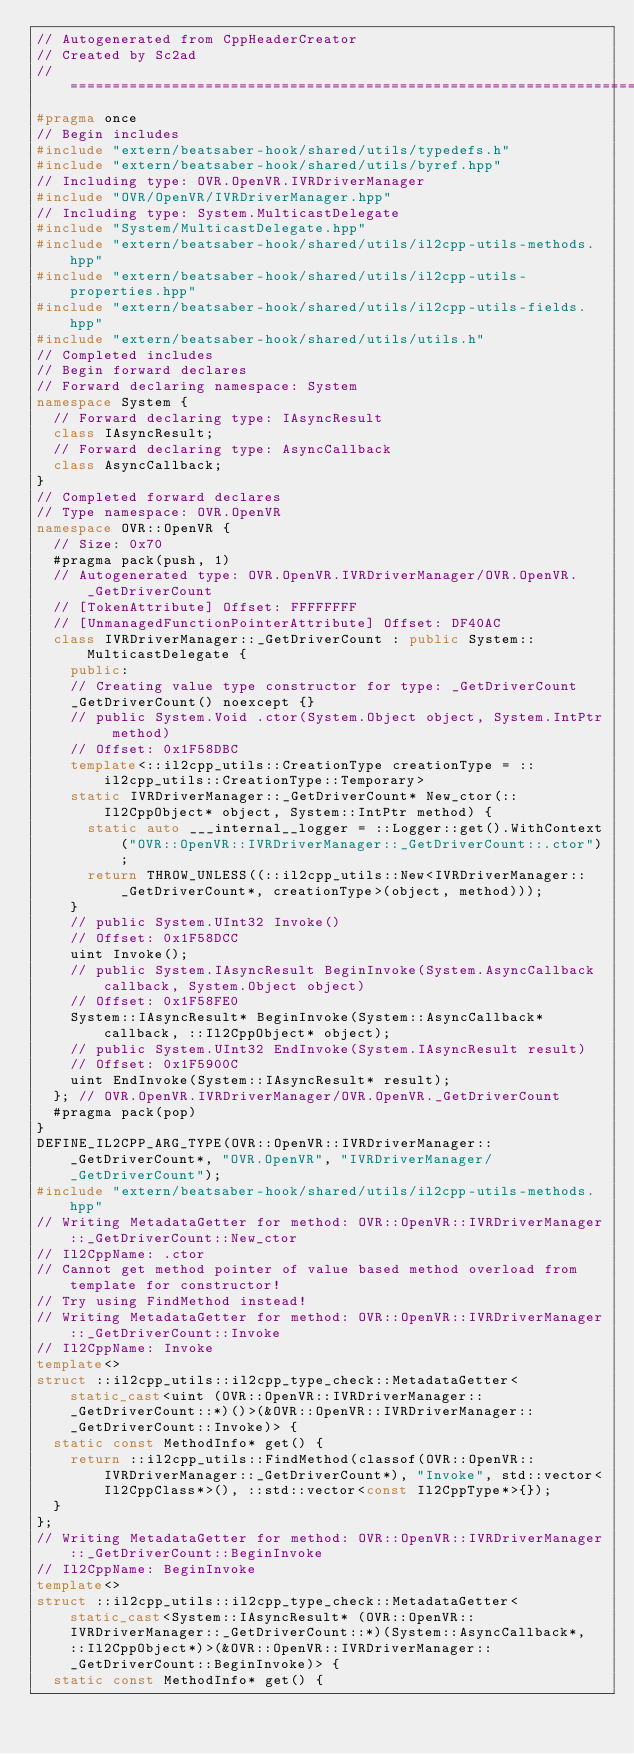<code> <loc_0><loc_0><loc_500><loc_500><_C++_>// Autogenerated from CppHeaderCreator
// Created by Sc2ad
// =========================================================================
#pragma once
// Begin includes
#include "extern/beatsaber-hook/shared/utils/typedefs.h"
#include "extern/beatsaber-hook/shared/utils/byref.hpp"
// Including type: OVR.OpenVR.IVRDriverManager
#include "OVR/OpenVR/IVRDriverManager.hpp"
// Including type: System.MulticastDelegate
#include "System/MulticastDelegate.hpp"
#include "extern/beatsaber-hook/shared/utils/il2cpp-utils-methods.hpp"
#include "extern/beatsaber-hook/shared/utils/il2cpp-utils-properties.hpp"
#include "extern/beatsaber-hook/shared/utils/il2cpp-utils-fields.hpp"
#include "extern/beatsaber-hook/shared/utils/utils.h"
// Completed includes
// Begin forward declares
// Forward declaring namespace: System
namespace System {
  // Forward declaring type: IAsyncResult
  class IAsyncResult;
  // Forward declaring type: AsyncCallback
  class AsyncCallback;
}
// Completed forward declares
// Type namespace: OVR.OpenVR
namespace OVR::OpenVR {
  // Size: 0x70
  #pragma pack(push, 1)
  // Autogenerated type: OVR.OpenVR.IVRDriverManager/OVR.OpenVR._GetDriverCount
  // [TokenAttribute] Offset: FFFFFFFF
  // [UnmanagedFunctionPointerAttribute] Offset: DF40AC
  class IVRDriverManager::_GetDriverCount : public System::MulticastDelegate {
    public:
    // Creating value type constructor for type: _GetDriverCount
    _GetDriverCount() noexcept {}
    // public System.Void .ctor(System.Object object, System.IntPtr method)
    // Offset: 0x1F58DBC
    template<::il2cpp_utils::CreationType creationType = ::il2cpp_utils::CreationType::Temporary>
    static IVRDriverManager::_GetDriverCount* New_ctor(::Il2CppObject* object, System::IntPtr method) {
      static auto ___internal__logger = ::Logger::get().WithContext("OVR::OpenVR::IVRDriverManager::_GetDriverCount::.ctor");
      return THROW_UNLESS((::il2cpp_utils::New<IVRDriverManager::_GetDriverCount*, creationType>(object, method)));
    }
    // public System.UInt32 Invoke()
    // Offset: 0x1F58DCC
    uint Invoke();
    // public System.IAsyncResult BeginInvoke(System.AsyncCallback callback, System.Object object)
    // Offset: 0x1F58FE0
    System::IAsyncResult* BeginInvoke(System::AsyncCallback* callback, ::Il2CppObject* object);
    // public System.UInt32 EndInvoke(System.IAsyncResult result)
    // Offset: 0x1F5900C
    uint EndInvoke(System::IAsyncResult* result);
  }; // OVR.OpenVR.IVRDriverManager/OVR.OpenVR._GetDriverCount
  #pragma pack(pop)
}
DEFINE_IL2CPP_ARG_TYPE(OVR::OpenVR::IVRDriverManager::_GetDriverCount*, "OVR.OpenVR", "IVRDriverManager/_GetDriverCount");
#include "extern/beatsaber-hook/shared/utils/il2cpp-utils-methods.hpp"
// Writing MetadataGetter for method: OVR::OpenVR::IVRDriverManager::_GetDriverCount::New_ctor
// Il2CppName: .ctor
// Cannot get method pointer of value based method overload from template for constructor!
// Try using FindMethod instead!
// Writing MetadataGetter for method: OVR::OpenVR::IVRDriverManager::_GetDriverCount::Invoke
// Il2CppName: Invoke
template<>
struct ::il2cpp_utils::il2cpp_type_check::MetadataGetter<static_cast<uint (OVR::OpenVR::IVRDriverManager::_GetDriverCount::*)()>(&OVR::OpenVR::IVRDriverManager::_GetDriverCount::Invoke)> {
  static const MethodInfo* get() {
    return ::il2cpp_utils::FindMethod(classof(OVR::OpenVR::IVRDriverManager::_GetDriverCount*), "Invoke", std::vector<Il2CppClass*>(), ::std::vector<const Il2CppType*>{});
  }
};
// Writing MetadataGetter for method: OVR::OpenVR::IVRDriverManager::_GetDriverCount::BeginInvoke
// Il2CppName: BeginInvoke
template<>
struct ::il2cpp_utils::il2cpp_type_check::MetadataGetter<static_cast<System::IAsyncResult* (OVR::OpenVR::IVRDriverManager::_GetDriverCount::*)(System::AsyncCallback*, ::Il2CppObject*)>(&OVR::OpenVR::IVRDriverManager::_GetDriverCount::BeginInvoke)> {
  static const MethodInfo* get() {</code> 